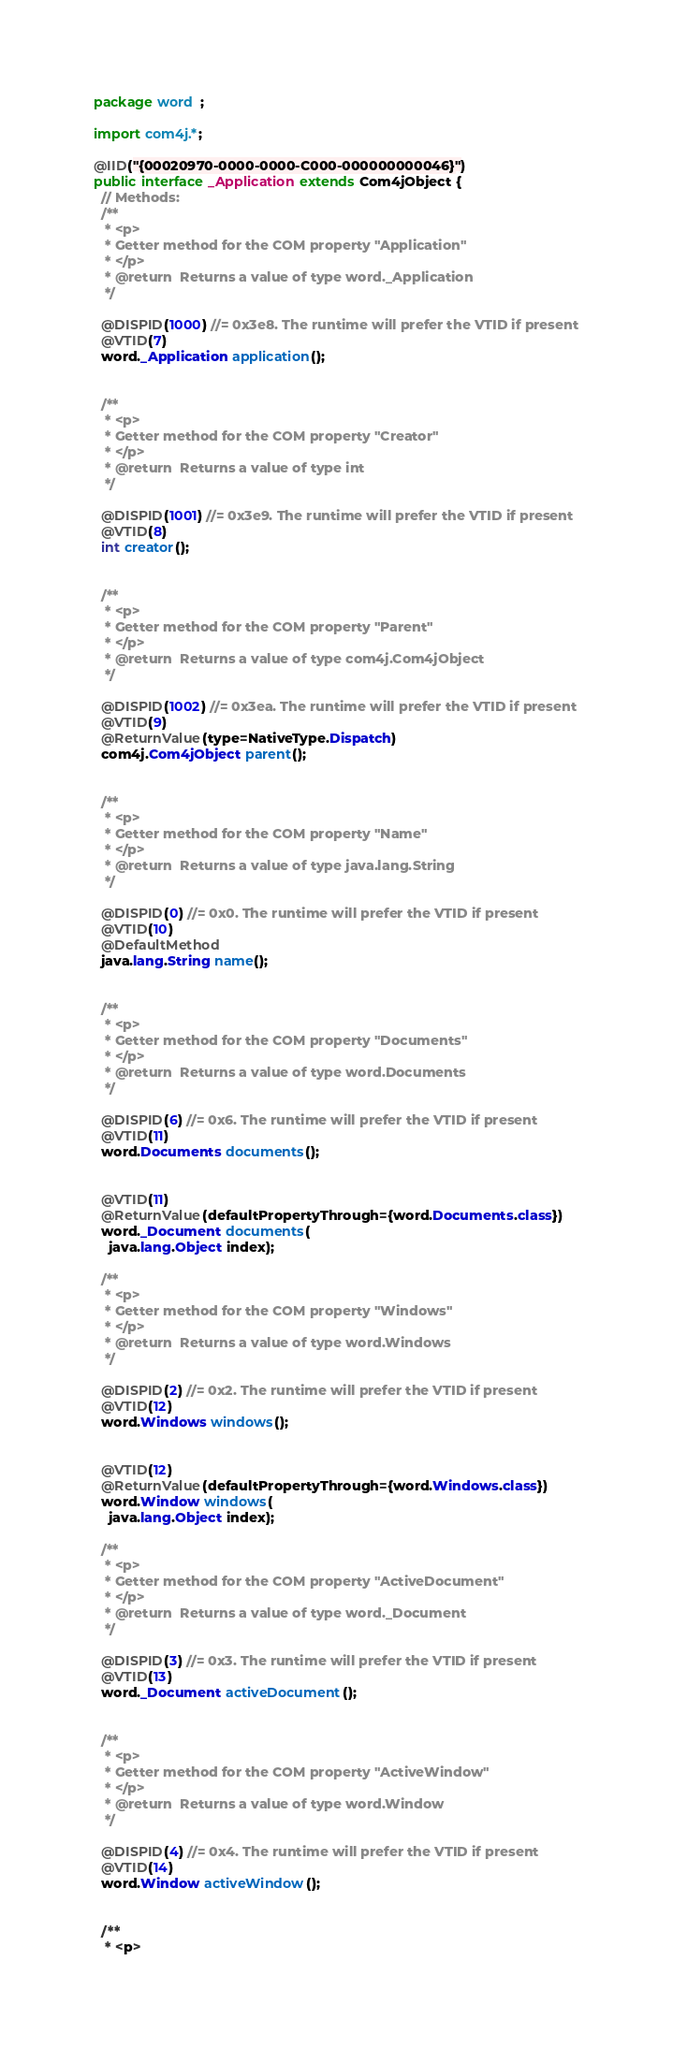<code> <loc_0><loc_0><loc_500><loc_500><_Java_>package word  ;

import com4j.*;

@IID("{00020970-0000-0000-C000-000000000046}")
public interface _Application extends Com4jObject {
  // Methods:
  /**
   * <p>
   * Getter method for the COM property "Application"
   * </p>
   * @return  Returns a value of type word._Application
   */

  @DISPID(1000) //= 0x3e8. The runtime will prefer the VTID if present
  @VTID(7)
  word._Application application();


  /**
   * <p>
   * Getter method for the COM property "Creator"
   * </p>
   * @return  Returns a value of type int
   */

  @DISPID(1001) //= 0x3e9. The runtime will prefer the VTID if present
  @VTID(8)
  int creator();


  /**
   * <p>
   * Getter method for the COM property "Parent"
   * </p>
   * @return  Returns a value of type com4j.Com4jObject
   */

  @DISPID(1002) //= 0x3ea. The runtime will prefer the VTID if present
  @VTID(9)
  @ReturnValue(type=NativeType.Dispatch)
  com4j.Com4jObject parent();


  /**
   * <p>
   * Getter method for the COM property "Name"
   * </p>
   * @return  Returns a value of type java.lang.String
   */

  @DISPID(0) //= 0x0. The runtime will prefer the VTID if present
  @VTID(10)
  @DefaultMethod
  java.lang.String name();


  /**
   * <p>
   * Getter method for the COM property "Documents"
   * </p>
   * @return  Returns a value of type word.Documents
   */

  @DISPID(6) //= 0x6. The runtime will prefer the VTID if present
  @VTID(11)
  word.Documents documents();


  @VTID(11)
  @ReturnValue(defaultPropertyThrough={word.Documents.class})
  word._Document documents(
    java.lang.Object index);

  /**
   * <p>
   * Getter method for the COM property "Windows"
   * </p>
   * @return  Returns a value of type word.Windows
   */

  @DISPID(2) //= 0x2. The runtime will prefer the VTID if present
  @VTID(12)
  word.Windows windows();


  @VTID(12)
  @ReturnValue(defaultPropertyThrough={word.Windows.class})
  word.Window windows(
    java.lang.Object index);

  /**
   * <p>
   * Getter method for the COM property "ActiveDocument"
   * </p>
   * @return  Returns a value of type word._Document
   */

  @DISPID(3) //= 0x3. The runtime will prefer the VTID if present
  @VTID(13)
  word._Document activeDocument();


  /**
   * <p>
   * Getter method for the COM property "ActiveWindow"
   * </p>
   * @return  Returns a value of type word.Window
   */

  @DISPID(4) //= 0x4. The runtime will prefer the VTID if present
  @VTID(14)
  word.Window activeWindow();


  /**
   * <p></code> 